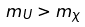Convert formula to latex. <formula><loc_0><loc_0><loc_500><loc_500>m _ { U } > m _ { \chi }</formula> 